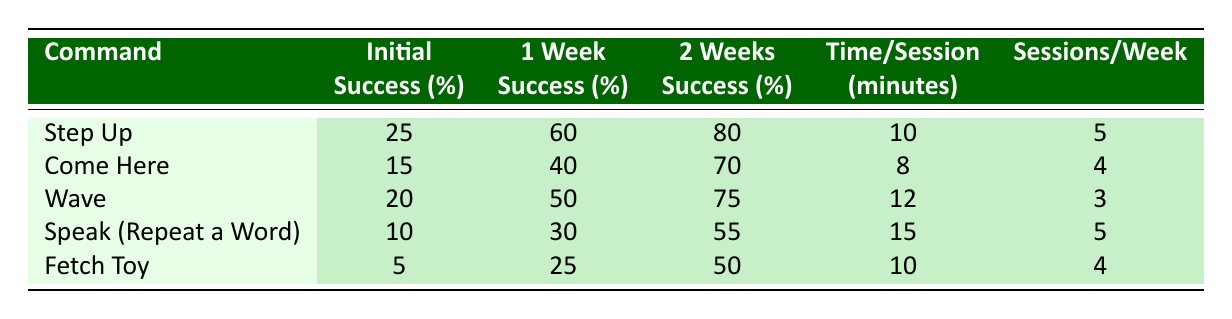What is the initial success rate for the command "Fetch Toy"? The table states that the initial success rate for "Fetch Toy" is listed directly in the relevant row.
Answer: 5 Which command has the highest average success rate after 2 weeks? Looking through the average success rates after 2 weeks, "Step Up" has the highest rate at 80%.
Answer: Step Up What is the average time spent per session for the command "Speak (Repeat a Word)"? The table provides the average time spent per session for each command, and for "Speak (Repeat a Word)", it is 15 minutes.
Answer: 15 Are the sessions per week for the command "Wave" and "Fetch Toy" the same? Checking the sessions per week column, "Wave" has 3 sessions and "Fetch Toy" has 4 sessions, so they are not the same.
Answer: No If you increase the time spent on the command "Come Here" by 2 minutes, what would the new average time spent per session be? The current time spent per session for "Come Here" is 8 minutes. Adding 2 minutes results in 8 + 2 = 10 minutes.
Answer: 10 Which command improves its success rate by the most significant percentage from the initial rate to after 2 weeks? Calculating the improvement for each command: "Step Up" improves by 55%, "Come Here" by 55%, "Wave" by 55%, "Speak" by 45%, and "Fetch Toy" by 45%. "Step Up", "Come Here", and "Wave" all improve the same amount, but the question asks for the command, which is "Step Up".
Answer: Step Up How much time, in total, would be spent training the command "Wave" in a week? The table indicates "Wave" requires 12 minutes per session and is trained 3 sessions a week. Therefore, total time spent = 12 minutes * 3 sessions = 36 minutes.
Answer: 36 Is the average success rate for "Speak (Repeat a Word)" after 1 week greater than 25%? "Speak (Repeat a Word)" has an average success rate after 1 week of 30%, which is greater than 25%.
Answer: Yes 